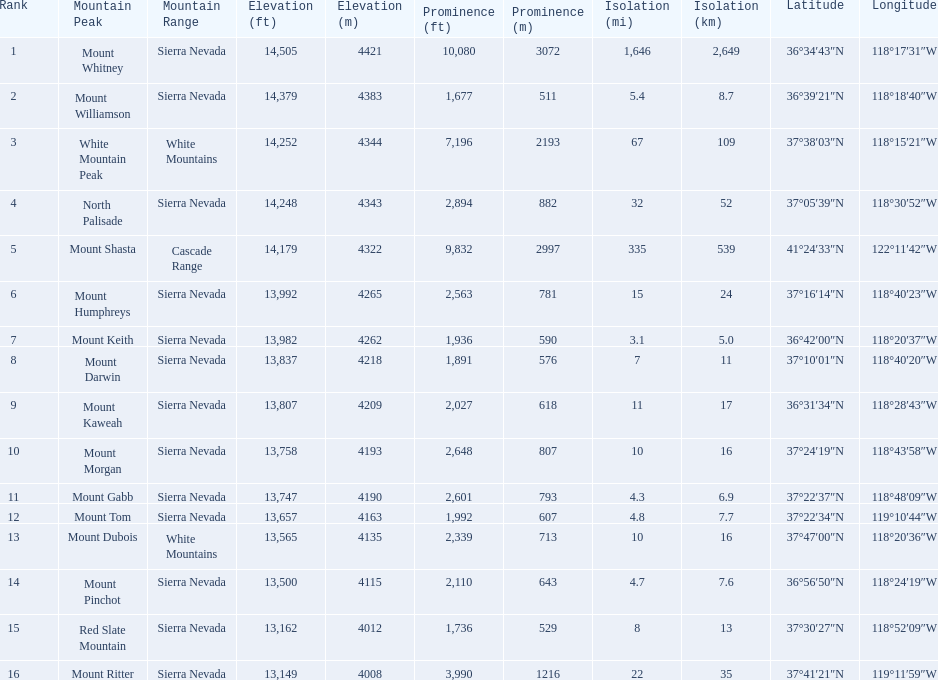What are the prominence lengths higher than 10,000 feet? 10,080 ft\n3072 m. What mountain peak has a prominence of 10,080 feet? Mount Whitney. 